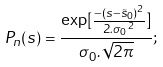<formula> <loc_0><loc_0><loc_500><loc_500>P _ { n } ( s ) = \frac { \exp [ \frac { - ( s - \tilde { s } _ { 0 } ) ^ { 2 } } { 2 . { \sigma _ { 0 } } ^ { 2 } } ] } { \sigma _ { 0 } . \sqrt { 2 \pi } } ;</formula> 